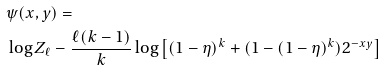Convert formula to latex. <formula><loc_0><loc_0><loc_500><loc_500>& \psi ( x , y ) = \\ & \log Z _ { \ell } - \frac { \ell ( k - 1 ) } { k } \log \left [ ( 1 - \eta ) ^ { k } + ( 1 - ( 1 - \eta ) ^ { k } ) 2 ^ { - x y } \right ]</formula> 